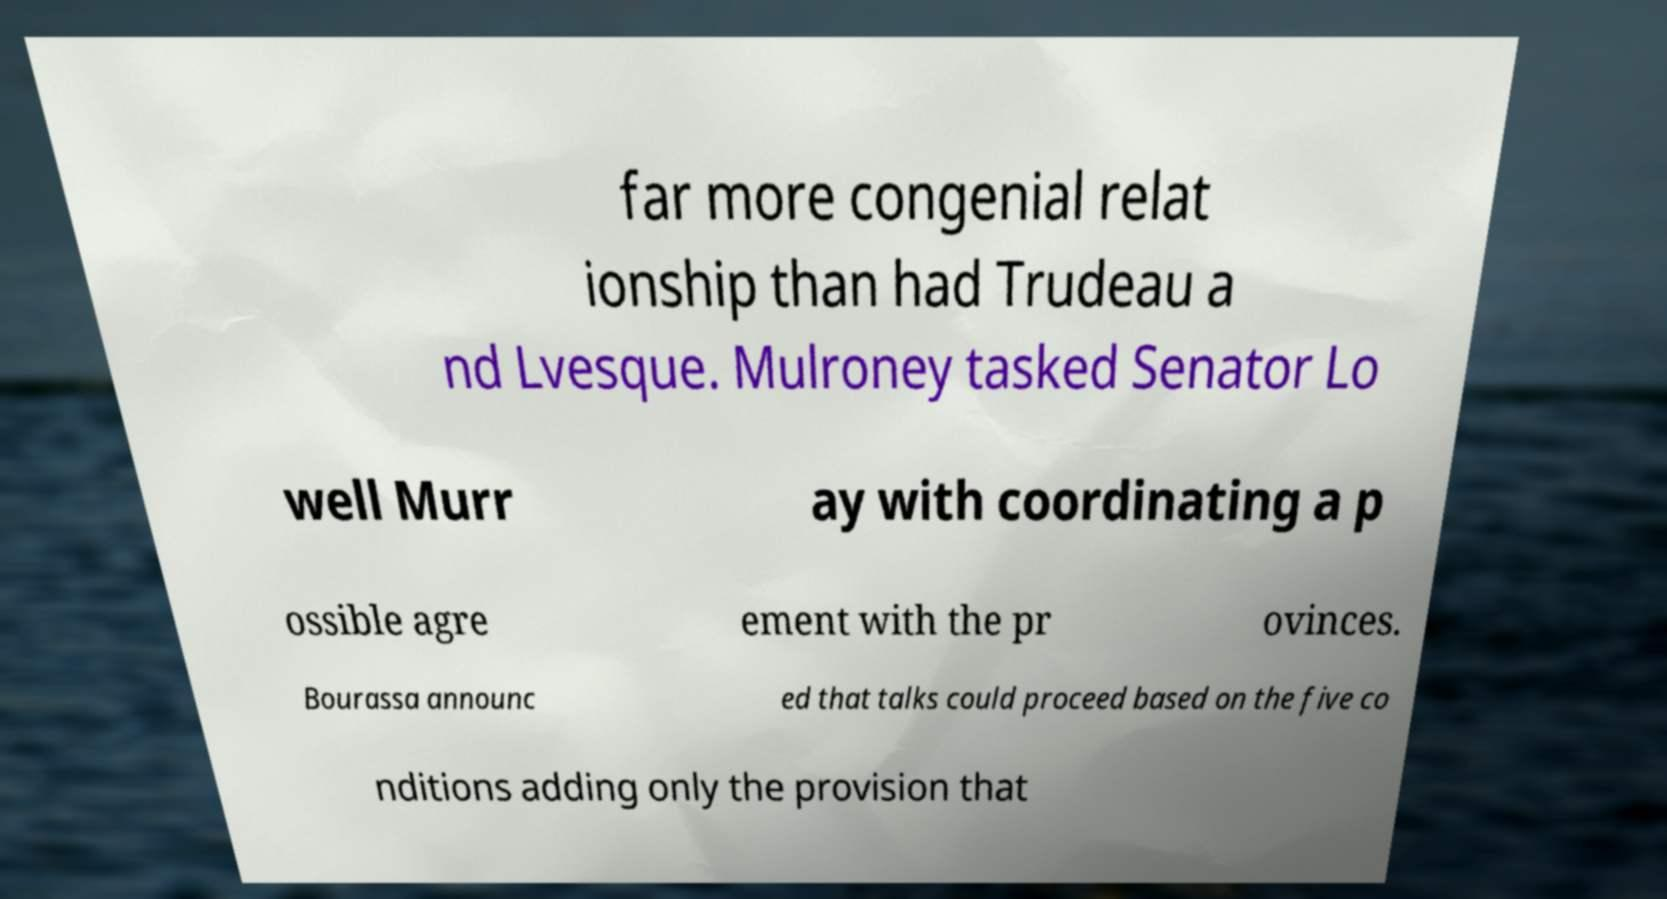Can you read and provide the text displayed in the image?This photo seems to have some interesting text. Can you extract and type it out for me? far more congenial relat ionship than had Trudeau a nd Lvesque. Mulroney tasked Senator Lo well Murr ay with coordinating a p ossible agre ement with the pr ovinces. Bourassa announc ed that talks could proceed based on the five co nditions adding only the provision that 